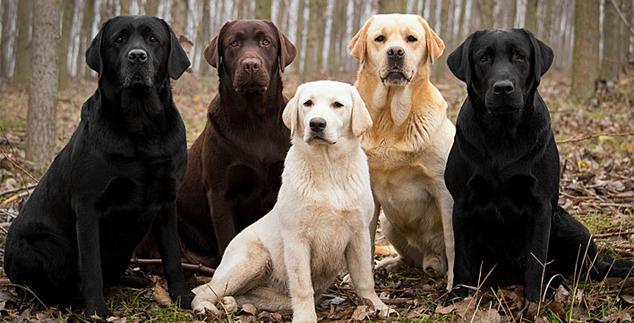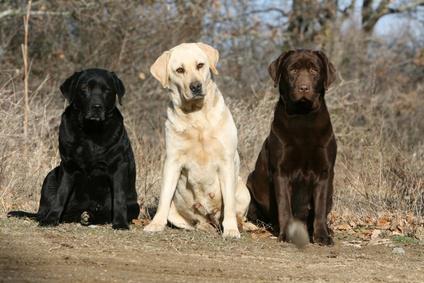The first image is the image on the left, the second image is the image on the right. Analyze the images presented: Is the assertion "The right image contains three dogs seated outside." valid? Answer yes or no. Yes. The first image is the image on the left, the second image is the image on the right. For the images shown, is this caption "An image shows three different solid color dogs posed side-by-side, with the black dog in the middle." true? Answer yes or no. No. 